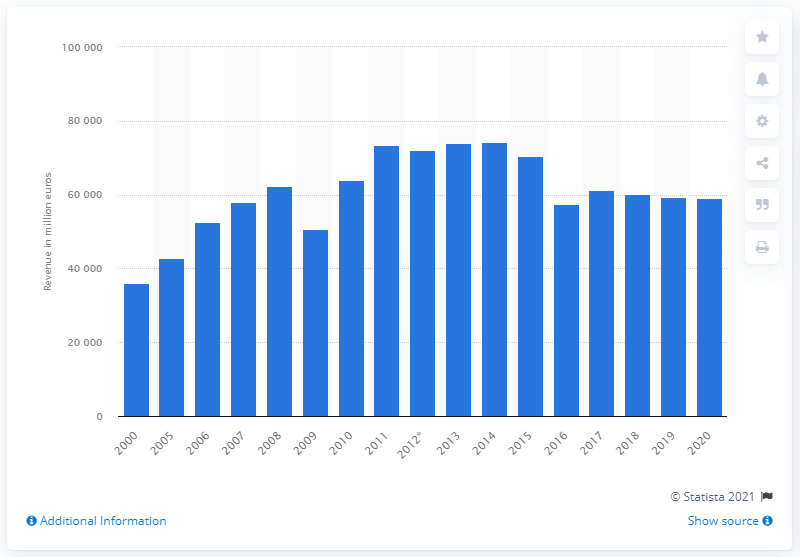List a handful of essential elements in this visual. BASF's revenue in 2020 was 59,149. 